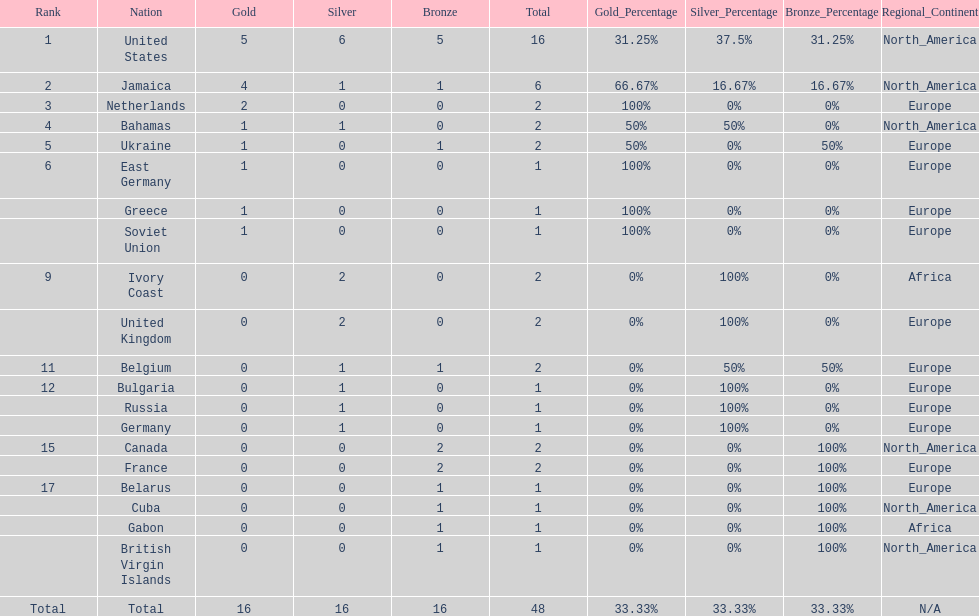What is the average number of gold medals won by the top 5 nations? 2.6. 